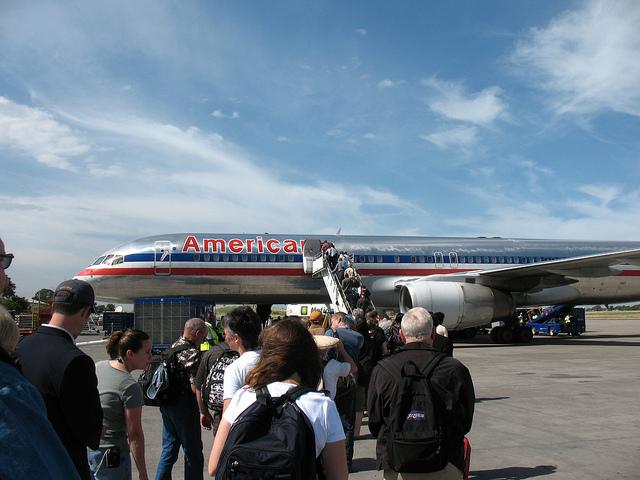Are the people boarding or deplaning?
Answer briefly. Boarding. What is the weather like?
Be succinct. Sunny. What airline does this plane belong to?
Short answer required. American. 